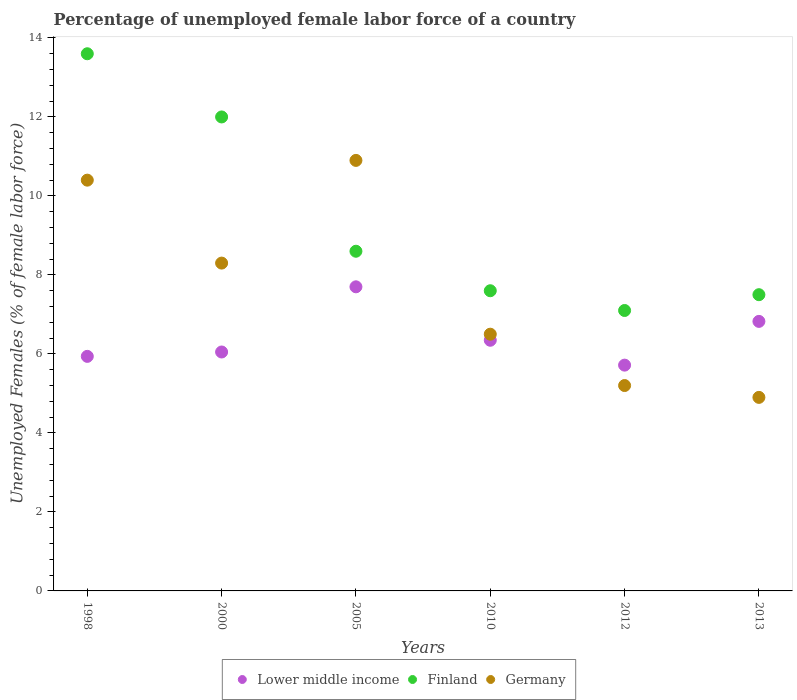What is the percentage of unemployed female labor force in Lower middle income in 2005?
Offer a very short reply. 7.7. Across all years, what is the maximum percentage of unemployed female labor force in Finland?
Your response must be concise. 13.6. Across all years, what is the minimum percentage of unemployed female labor force in Finland?
Offer a terse response. 7.1. In which year was the percentage of unemployed female labor force in Lower middle income maximum?
Your answer should be very brief. 2005. In which year was the percentage of unemployed female labor force in Finland minimum?
Keep it short and to the point. 2012. What is the total percentage of unemployed female labor force in Finland in the graph?
Your answer should be compact. 56.4. What is the difference between the percentage of unemployed female labor force in Lower middle income in 2000 and that in 2010?
Offer a very short reply. -0.3. What is the difference between the percentage of unemployed female labor force in Germany in 1998 and the percentage of unemployed female labor force in Lower middle income in 2010?
Offer a very short reply. 4.05. What is the average percentage of unemployed female labor force in Lower middle income per year?
Give a very brief answer. 6.43. In the year 2005, what is the difference between the percentage of unemployed female labor force in Finland and percentage of unemployed female labor force in Germany?
Ensure brevity in your answer.  -2.3. In how many years, is the percentage of unemployed female labor force in Finland greater than 10 %?
Your response must be concise. 2. What is the ratio of the percentage of unemployed female labor force in Germany in 2010 to that in 2012?
Make the answer very short. 1.25. Is the percentage of unemployed female labor force in Germany in 1998 less than that in 2000?
Ensure brevity in your answer.  No. Is the difference between the percentage of unemployed female labor force in Finland in 1998 and 2005 greater than the difference between the percentage of unemployed female labor force in Germany in 1998 and 2005?
Your response must be concise. Yes. What is the difference between the highest and the lowest percentage of unemployed female labor force in Germany?
Offer a terse response. 6. Is the sum of the percentage of unemployed female labor force in Lower middle income in 2000 and 2013 greater than the maximum percentage of unemployed female labor force in Germany across all years?
Ensure brevity in your answer.  Yes. Does the percentage of unemployed female labor force in Germany monotonically increase over the years?
Make the answer very short. No. Is the percentage of unemployed female labor force in Finland strictly greater than the percentage of unemployed female labor force in Lower middle income over the years?
Give a very brief answer. Yes. Is the percentage of unemployed female labor force in Finland strictly less than the percentage of unemployed female labor force in Germany over the years?
Ensure brevity in your answer.  No. How many years are there in the graph?
Your response must be concise. 6. What is the difference between two consecutive major ticks on the Y-axis?
Provide a short and direct response. 2. How are the legend labels stacked?
Offer a terse response. Horizontal. What is the title of the graph?
Offer a terse response. Percentage of unemployed female labor force of a country. What is the label or title of the Y-axis?
Offer a terse response. Unemployed Females (% of female labor force). What is the Unemployed Females (% of female labor force) of Lower middle income in 1998?
Make the answer very short. 5.94. What is the Unemployed Females (% of female labor force) of Finland in 1998?
Give a very brief answer. 13.6. What is the Unemployed Females (% of female labor force) in Germany in 1998?
Offer a terse response. 10.4. What is the Unemployed Females (% of female labor force) in Lower middle income in 2000?
Give a very brief answer. 6.05. What is the Unemployed Females (% of female labor force) of Finland in 2000?
Keep it short and to the point. 12. What is the Unemployed Females (% of female labor force) in Germany in 2000?
Provide a short and direct response. 8.3. What is the Unemployed Females (% of female labor force) in Lower middle income in 2005?
Make the answer very short. 7.7. What is the Unemployed Females (% of female labor force) in Finland in 2005?
Keep it short and to the point. 8.6. What is the Unemployed Females (% of female labor force) of Germany in 2005?
Ensure brevity in your answer.  10.9. What is the Unemployed Females (% of female labor force) of Lower middle income in 2010?
Your response must be concise. 6.35. What is the Unemployed Females (% of female labor force) in Finland in 2010?
Offer a very short reply. 7.6. What is the Unemployed Females (% of female labor force) of Lower middle income in 2012?
Provide a succinct answer. 5.72. What is the Unemployed Females (% of female labor force) in Finland in 2012?
Your answer should be compact. 7.1. What is the Unemployed Females (% of female labor force) of Germany in 2012?
Your answer should be very brief. 5.2. What is the Unemployed Females (% of female labor force) in Lower middle income in 2013?
Ensure brevity in your answer.  6.82. What is the Unemployed Females (% of female labor force) in Finland in 2013?
Your response must be concise. 7.5. What is the Unemployed Females (% of female labor force) of Germany in 2013?
Your answer should be very brief. 4.9. Across all years, what is the maximum Unemployed Females (% of female labor force) in Lower middle income?
Your answer should be compact. 7.7. Across all years, what is the maximum Unemployed Females (% of female labor force) of Finland?
Offer a terse response. 13.6. Across all years, what is the maximum Unemployed Females (% of female labor force) of Germany?
Your answer should be very brief. 10.9. Across all years, what is the minimum Unemployed Females (% of female labor force) in Lower middle income?
Your response must be concise. 5.72. Across all years, what is the minimum Unemployed Females (% of female labor force) of Finland?
Offer a very short reply. 7.1. Across all years, what is the minimum Unemployed Females (% of female labor force) in Germany?
Offer a very short reply. 4.9. What is the total Unemployed Females (% of female labor force) in Lower middle income in the graph?
Make the answer very short. 38.57. What is the total Unemployed Females (% of female labor force) of Finland in the graph?
Your answer should be very brief. 56.4. What is the total Unemployed Females (% of female labor force) in Germany in the graph?
Make the answer very short. 46.2. What is the difference between the Unemployed Females (% of female labor force) in Lower middle income in 1998 and that in 2000?
Provide a succinct answer. -0.11. What is the difference between the Unemployed Females (% of female labor force) in Finland in 1998 and that in 2000?
Offer a terse response. 1.6. What is the difference between the Unemployed Females (% of female labor force) in Germany in 1998 and that in 2000?
Your answer should be very brief. 2.1. What is the difference between the Unemployed Females (% of female labor force) of Lower middle income in 1998 and that in 2005?
Ensure brevity in your answer.  -1.76. What is the difference between the Unemployed Females (% of female labor force) of Finland in 1998 and that in 2005?
Provide a succinct answer. 5. What is the difference between the Unemployed Females (% of female labor force) of Germany in 1998 and that in 2005?
Give a very brief answer. -0.5. What is the difference between the Unemployed Females (% of female labor force) of Lower middle income in 1998 and that in 2010?
Your response must be concise. -0.41. What is the difference between the Unemployed Females (% of female labor force) of Germany in 1998 and that in 2010?
Give a very brief answer. 3.9. What is the difference between the Unemployed Females (% of female labor force) in Lower middle income in 1998 and that in 2012?
Offer a terse response. 0.22. What is the difference between the Unemployed Females (% of female labor force) in Finland in 1998 and that in 2012?
Provide a short and direct response. 6.5. What is the difference between the Unemployed Females (% of female labor force) of Germany in 1998 and that in 2012?
Offer a terse response. 5.2. What is the difference between the Unemployed Females (% of female labor force) in Lower middle income in 1998 and that in 2013?
Your answer should be very brief. -0.89. What is the difference between the Unemployed Females (% of female labor force) of Germany in 1998 and that in 2013?
Ensure brevity in your answer.  5.5. What is the difference between the Unemployed Females (% of female labor force) of Lower middle income in 2000 and that in 2005?
Offer a terse response. -1.65. What is the difference between the Unemployed Females (% of female labor force) of Lower middle income in 2000 and that in 2010?
Offer a very short reply. -0.3. What is the difference between the Unemployed Females (% of female labor force) of Finland in 2000 and that in 2010?
Give a very brief answer. 4.4. What is the difference between the Unemployed Females (% of female labor force) in Germany in 2000 and that in 2010?
Provide a short and direct response. 1.8. What is the difference between the Unemployed Females (% of female labor force) in Lower middle income in 2000 and that in 2012?
Provide a short and direct response. 0.33. What is the difference between the Unemployed Females (% of female labor force) in Finland in 2000 and that in 2012?
Your response must be concise. 4.9. What is the difference between the Unemployed Females (% of female labor force) in Germany in 2000 and that in 2012?
Your answer should be compact. 3.1. What is the difference between the Unemployed Females (% of female labor force) of Lower middle income in 2000 and that in 2013?
Offer a very short reply. -0.77. What is the difference between the Unemployed Females (% of female labor force) of Finland in 2000 and that in 2013?
Ensure brevity in your answer.  4.5. What is the difference between the Unemployed Females (% of female labor force) of Germany in 2000 and that in 2013?
Keep it short and to the point. 3.4. What is the difference between the Unemployed Females (% of female labor force) in Lower middle income in 2005 and that in 2010?
Your answer should be compact. 1.35. What is the difference between the Unemployed Females (% of female labor force) of Finland in 2005 and that in 2010?
Keep it short and to the point. 1. What is the difference between the Unemployed Females (% of female labor force) in Germany in 2005 and that in 2010?
Provide a short and direct response. 4.4. What is the difference between the Unemployed Females (% of female labor force) in Lower middle income in 2005 and that in 2012?
Offer a terse response. 1.98. What is the difference between the Unemployed Females (% of female labor force) in Finland in 2005 and that in 2012?
Keep it short and to the point. 1.5. What is the difference between the Unemployed Females (% of female labor force) of Germany in 2005 and that in 2012?
Ensure brevity in your answer.  5.7. What is the difference between the Unemployed Females (% of female labor force) of Lower middle income in 2005 and that in 2013?
Give a very brief answer. 0.88. What is the difference between the Unemployed Females (% of female labor force) of Lower middle income in 2010 and that in 2012?
Provide a succinct answer. 0.63. What is the difference between the Unemployed Females (% of female labor force) of Germany in 2010 and that in 2012?
Your answer should be compact. 1.3. What is the difference between the Unemployed Females (% of female labor force) in Lower middle income in 2010 and that in 2013?
Your answer should be compact. -0.48. What is the difference between the Unemployed Females (% of female labor force) in Finland in 2010 and that in 2013?
Your response must be concise. 0.1. What is the difference between the Unemployed Females (% of female labor force) of Lower middle income in 2012 and that in 2013?
Keep it short and to the point. -1.11. What is the difference between the Unemployed Females (% of female labor force) of Lower middle income in 1998 and the Unemployed Females (% of female labor force) of Finland in 2000?
Give a very brief answer. -6.06. What is the difference between the Unemployed Females (% of female labor force) in Lower middle income in 1998 and the Unemployed Females (% of female labor force) in Germany in 2000?
Your answer should be very brief. -2.36. What is the difference between the Unemployed Females (% of female labor force) of Lower middle income in 1998 and the Unemployed Females (% of female labor force) of Finland in 2005?
Make the answer very short. -2.66. What is the difference between the Unemployed Females (% of female labor force) of Lower middle income in 1998 and the Unemployed Females (% of female labor force) of Germany in 2005?
Your answer should be compact. -4.96. What is the difference between the Unemployed Females (% of female labor force) in Lower middle income in 1998 and the Unemployed Females (% of female labor force) in Finland in 2010?
Your answer should be compact. -1.66. What is the difference between the Unemployed Females (% of female labor force) in Lower middle income in 1998 and the Unemployed Females (% of female labor force) in Germany in 2010?
Keep it short and to the point. -0.56. What is the difference between the Unemployed Females (% of female labor force) in Finland in 1998 and the Unemployed Females (% of female labor force) in Germany in 2010?
Your answer should be compact. 7.1. What is the difference between the Unemployed Females (% of female labor force) of Lower middle income in 1998 and the Unemployed Females (% of female labor force) of Finland in 2012?
Give a very brief answer. -1.16. What is the difference between the Unemployed Females (% of female labor force) in Lower middle income in 1998 and the Unemployed Females (% of female labor force) in Germany in 2012?
Provide a succinct answer. 0.74. What is the difference between the Unemployed Females (% of female labor force) in Lower middle income in 1998 and the Unemployed Females (% of female labor force) in Finland in 2013?
Offer a very short reply. -1.56. What is the difference between the Unemployed Females (% of female labor force) of Finland in 1998 and the Unemployed Females (% of female labor force) of Germany in 2013?
Provide a succinct answer. 8.7. What is the difference between the Unemployed Females (% of female labor force) of Lower middle income in 2000 and the Unemployed Females (% of female labor force) of Finland in 2005?
Offer a terse response. -2.55. What is the difference between the Unemployed Females (% of female labor force) in Lower middle income in 2000 and the Unemployed Females (% of female labor force) in Germany in 2005?
Provide a short and direct response. -4.85. What is the difference between the Unemployed Females (% of female labor force) in Lower middle income in 2000 and the Unemployed Females (% of female labor force) in Finland in 2010?
Your answer should be compact. -1.55. What is the difference between the Unemployed Females (% of female labor force) of Lower middle income in 2000 and the Unemployed Females (% of female labor force) of Germany in 2010?
Your answer should be compact. -0.45. What is the difference between the Unemployed Females (% of female labor force) of Finland in 2000 and the Unemployed Females (% of female labor force) of Germany in 2010?
Provide a short and direct response. 5.5. What is the difference between the Unemployed Females (% of female labor force) of Lower middle income in 2000 and the Unemployed Females (% of female labor force) of Finland in 2012?
Keep it short and to the point. -1.05. What is the difference between the Unemployed Females (% of female labor force) of Lower middle income in 2000 and the Unemployed Females (% of female labor force) of Germany in 2012?
Keep it short and to the point. 0.85. What is the difference between the Unemployed Females (% of female labor force) of Finland in 2000 and the Unemployed Females (% of female labor force) of Germany in 2012?
Offer a very short reply. 6.8. What is the difference between the Unemployed Females (% of female labor force) in Lower middle income in 2000 and the Unemployed Females (% of female labor force) in Finland in 2013?
Your answer should be very brief. -1.45. What is the difference between the Unemployed Females (% of female labor force) of Lower middle income in 2000 and the Unemployed Females (% of female labor force) of Germany in 2013?
Ensure brevity in your answer.  1.15. What is the difference between the Unemployed Females (% of female labor force) of Lower middle income in 2005 and the Unemployed Females (% of female labor force) of Finland in 2010?
Offer a very short reply. 0.1. What is the difference between the Unemployed Females (% of female labor force) of Lower middle income in 2005 and the Unemployed Females (% of female labor force) of Germany in 2010?
Give a very brief answer. 1.2. What is the difference between the Unemployed Females (% of female labor force) in Finland in 2005 and the Unemployed Females (% of female labor force) in Germany in 2010?
Give a very brief answer. 2.1. What is the difference between the Unemployed Females (% of female labor force) in Lower middle income in 2005 and the Unemployed Females (% of female labor force) in Finland in 2012?
Provide a succinct answer. 0.6. What is the difference between the Unemployed Females (% of female labor force) in Lower middle income in 2005 and the Unemployed Females (% of female labor force) in Germany in 2012?
Keep it short and to the point. 2.5. What is the difference between the Unemployed Females (% of female labor force) in Lower middle income in 2005 and the Unemployed Females (% of female labor force) in Finland in 2013?
Keep it short and to the point. 0.2. What is the difference between the Unemployed Females (% of female labor force) of Lower middle income in 2005 and the Unemployed Females (% of female labor force) of Germany in 2013?
Your answer should be very brief. 2.8. What is the difference between the Unemployed Females (% of female labor force) in Finland in 2005 and the Unemployed Females (% of female labor force) in Germany in 2013?
Ensure brevity in your answer.  3.7. What is the difference between the Unemployed Females (% of female labor force) in Lower middle income in 2010 and the Unemployed Females (% of female labor force) in Finland in 2012?
Make the answer very short. -0.75. What is the difference between the Unemployed Females (% of female labor force) in Lower middle income in 2010 and the Unemployed Females (% of female labor force) in Germany in 2012?
Ensure brevity in your answer.  1.15. What is the difference between the Unemployed Females (% of female labor force) in Finland in 2010 and the Unemployed Females (% of female labor force) in Germany in 2012?
Your answer should be compact. 2.4. What is the difference between the Unemployed Females (% of female labor force) of Lower middle income in 2010 and the Unemployed Females (% of female labor force) of Finland in 2013?
Keep it short and to the point. -1.15. What is the difference between the Unemployed Females (% of female labor force) of Lower middle income in 2010 and the Unemployed Females (% of female labor force) of Germany in 2013?
Provide a short and direct response. 1.45. What is the difference between the Unemployed Females (% of female labor force) of Finland in 2010 and the Unemployed Females (% of female labor force) of Germany in 2013?
Give a very brief answer. 2.7. What is the difference between the Unemployed Females (% of female labor force) of Lower middle income in 2012 and the Unemployed Females (% of female labor force) of Finland in 2013?
Provide a succinct answer. -1.78. What is the difference between the Unemployed Females (% of female labor force) in Lower middle income in 2012 and the Unemployed Females (% of female labor force) in Germany in 2013?
Provide a short and direct response. 0.82. What is the average Unemployed Females (% of female labor force) of Lower middle income per year?
Your response must be concise. 6.43. What is the average Unemployed Females (% of female labor force) of Germany per year?
Give a very brief answer. 7.7. In the year 1998, what is the difference between the Unemployed Females (% of female labor force) in Lower middle income and Unemployed Females (% of female labor force) in Finland?
Your answer should be very brief. -7.66. In the year 1998, what is the difference between the Unemployed Females (% of female labor force) in Lower middle income and Unemployed Females (% of female labor force) in Germany?
Offer a terse response. -4.46. In the year 1998, what is the difference between the Unemployed Females (% of female labor force) of Finland and Unemployed Females (% of female labor force) of Germany?
Your response must be concise. 3.2. In the year 2000, what is the difference between the Unemployed Females (% of female labor force) in Lower middle income and Unemployed Females (% of female labor force) in Finland?
Provide a succinct answer. -5.95. In the year 2000, what is the difference between the Unemployed Females (% of female labor force) in Lower middle income and Unemployed Females (% of female labor force) in Germany?
Offer a very short reply. -2.25. In the year 2000, what is the difference between the Unemployed Females (% of female labor force) of Finland and Unemployed Females (% of female labor force) of Germany?
Give a very brief answer. 3.7. In the year 2005, what is the difference between the Unemployed Females (% of female labor force) of Lower middle income and Unemployed Females (% of female labor force) of Finland?
Your answer should be compact. -0.9. In the year 2005, what is the difference between the Unemployed Females (% of female labor force) of Lower middle income and Unemployed Females (% of female labor force) of Germany?
Your answer should be compact. -3.2. In the year 2005, what is the difference between the Unemployed Females (% of female labor force) in Finland and Unemployed Females (% of female labor force) in Germany?
Keep it short and to the point. -2.3. In the year 2010, what is the difference between the Unemployed Females (% of female labor force) of Lower middle income and Unemployed Females (% of female labor force) of Finland?
Your answer should be compact. -1.25. In the year 2010, what is the difference between the Unemployed Females (% of female labor force) of Lower middle income and Unemployed Females (% of female labor force) of Germany?
Give a very brief answer. -0.15. In the year 2012, what is the difference between the Unemployed Females (% of female labor force) of Lower middle income and Unemployed Females (% of female labor force) of Finland?
Offer a terse response. -1.38. In the year 2012, what is the difference between the Unemployed Females (% of female labor force) in Lower middle income and Unemployed Females (% of female labor force) in Germany?
Ensure brevity in your answer.  0.52. In the year 2012, what is the difference between the Unemployed Females (% of female labor force) in Finland and Unemployed Females (% of female labor force) in Germany?
Your answer should be compact. 1.9. In the year 2013, what is the difference between the Unemployed Females (% of female labor force) in Lower middle income and Unemployed Females (% of female labor force) in Finland?
Give a very brief answer. -0.68. In the year 2013, what is the difference between the Unemployed Females (% of female labor force) of Lower middle income and Unemployed Females (% of female labor force) of Germany?
Make the answer very short. 1.92. In the year 2013, what is the difference between the Unemployed Females (% of female labor force) of Finland and Unemployed Females (% of female labor force) of Germany?
Offer a very short reply. 2.6. What is the ratio of the Unemployed Females (% of female labor force) of Lower middle income in 1998 to that in 2000?
Keep it short and to the point. 0.98. What is the ratio of the Unemployed Females (% of female labor force) in Finland in 1998 to that in 2000?
Your answer should be compact. 1.13. What is the ratio of the Unemployed Females (% of female labor force) of Germany in 1998 to that in 2000?
Your answer should be very brief. 1.25. What is the ratio of the Unemployed Females (% of female labor force) in Lower middle income in 1998 to that in 2005?
Your answer should be very brief. 0.77. What is the ratio of the Unemployed Females (% of female labor force) of Finland in 1998 to that in 2005?
Provide a short and direct response. 1.58. What is the ratio of the Unemployed Females (% of female labor force) of Germany in 1998 to that in 2005?
Ensure brevity in your answer.  0.95. What is the ratio of the Unemployed Females (% of female labor force) of Lower middle income in 1998 to that in 2010?
Your response must be concise. 0.94. What is the ratio of the Unemployed Females (% of female labor force) of Finland in 1998 to that in 2010?
Your answer should be compact. 1.79. What is the ratio of the Unemployed Females (% of female labor force) in Lower middle income in 1998 to that in 2012?
Make the answer very short. 1.04. What is the ratio of the Unemployed Females (% of female labor force) of Finland in 1998 to that in 2012?
Give a very brief answer. 1.92. What is the ratio of the Unemployed Females (% of female labor force) in Lower middle income in 1998 to that in 2013?
Provide a succinct answer. 0.87. What is the ratio of the Unemployed Females (% of female labor force) of Finland in 1998 to that in 2013?
Your answer should be very brief. 1.81. What is the ratio of the Unemployed Females (% of female labor force) in Germany in 1998 to that in 2013?
Make the answer very short. 2.12. What is the ratio of the Unemployed Females (% of female labor force) in Lower middle income in 2000 to that in 2005?
Your answer should be compact. 0.79. What is the ratio of the Unemployed Females (% of female labor force) in Finland in 2000 to that in 2005?
Provide a succinct answer. 1.4. What is the ratio of the Unemployed Females (% of female labor force) of Germany in 2000 to that in 2005?
Keep it short and to the point. 0.76. What is the ratio of the Unemployed Females (% of female labor force) in Lower middle income in 2000 to that in 2010?
Your response must be concise. 0.95. What is the ratio of the Unemployed Females (% of female labor force) of Finland in 2000 to that in 2010?
Make the answer very short. 1.58. What is the ratio of the Unemployed Females (% of female labor force) in Germany in 2000 to that in 2010?
Your answer should be very brief. 1.28. What is the ratio of the Unemployed Females (% of female labor force) of Lower middle income in 2000 to that in 2012?
Keep it short and to the point. 1.06. What is the ratio of the Unemployed Females (% of female labor force) in Finland in 2000 to that in 2012?
Keep it short and to the point. 1.69. What is the ratio of the Unemployed Females (% of female labor force) of Germany in 2000 to that in 2012?
Give a very brief answer. 1.6. What is the ratio of the Unemployed Females (% of female labor force) of Lower middle income in 2000 to that in 2013?
Keep it short and to the point. 0.89. What is the ratio of the Unemployed Females (% of female labor force) in Germany in 2000 to that in 2013?
Offer a very short reply. 1.69. What is the ratio of the Unemployed Females (% of female labor force) of Lower middle income in 2005 to that in 2010?
Your answer should be very brief. 1.21. What is the ratio of the Unemployed Females (% of female labor force) of Finland in 2005 to that in 2010?
Your response must be concise. 1.13. What is the ratio of the Unemployed Females (% of female labor force) in Germany in 2005 to that in 2010?
Keep it short and to the point. 1.68. What is the ratio of the Unemployed Females (% of female labor force) in Lower middle income in 2005 to that in 2012?
Provide a succinct answer. 1.35. What is the ratio of the Unemployed Females (% of female labor force) of Finland in 2005 to that in 2012?
Give a very brief answer. 1.21. What is the ratio of the Unemployed Females (% of female labor force) in Germany in 2005 to that in 2012?
Your response must be concise. 2.1. What is the ratio of the Unemployed Females (% of female labor force) of Lower middle income in 2005 to that in 2013?
Provide a short and direct response. 1.13. What is the ratio of the Unemployed Females (% of female labor force) of Finland in 2005 to that in 2013?
Offer a terse response. 1.15. What is the ratio of the Unemployed Females (% of female labor force) of Germany in 2005 to that in 2013?
Your answer should be compact. 2.22. What is the ratio of the Unemployed Females (% of female labor force) of Lower middle income in 2010 to that in 2012?
Offer a terse response. 1.11. What is the ratio of the Unemployed Females (% of female labor force) of Finland in 2010 to that in 2012?
Your answer should be compact. 1.07. What is the ratio of the Unemployed Females (% of female labor force) in Germany in 2010 to that in 2012?
Offer a very short reply. 1.25. What is the ratio of the Unemployed Females (% of female labor force) in Finland in 2010 to that in 2013?
Provide a short and direct response. 1.01. What is the ratio of the Unemployed Females (% of female labor force) in Germany in 2010 to that in 2013?
Your answer should be compact. 1.33. What is the ratio of the Unemployed Females (% of female labor force) of Lower middle income in 2012 to that in 2013?
Offer a terse response. 0.84. What is the ratio of the Unemployed Females (% of female labor force) of Finland in 2012 to that in 2013?
Your response must be concise. 0.95. What is the ratio of the Unemployed Females (% of female labor force) of Germany in 2012 to that in 2013?
Keep it short and to the point. 1.06. What is the difference between the highest and the second highest Unemployed Females (% of female labor force) in Lower middle income?
Your answer should be compact. 0.88. What is the difference between the highest and the lowest Unemployed Females (% of female labor force) of Lower middle income?
Ensure brevity in your answer.  1.98. What is the difference between the highest and the lowest Unemployed Females (% of female labor force) of Finland?
Give a very brief answer. 6.5. What is the difference between the highest and the lowest Unemployed Females (% of female labor force) in Germany?
Your answer should be compact. 6. 